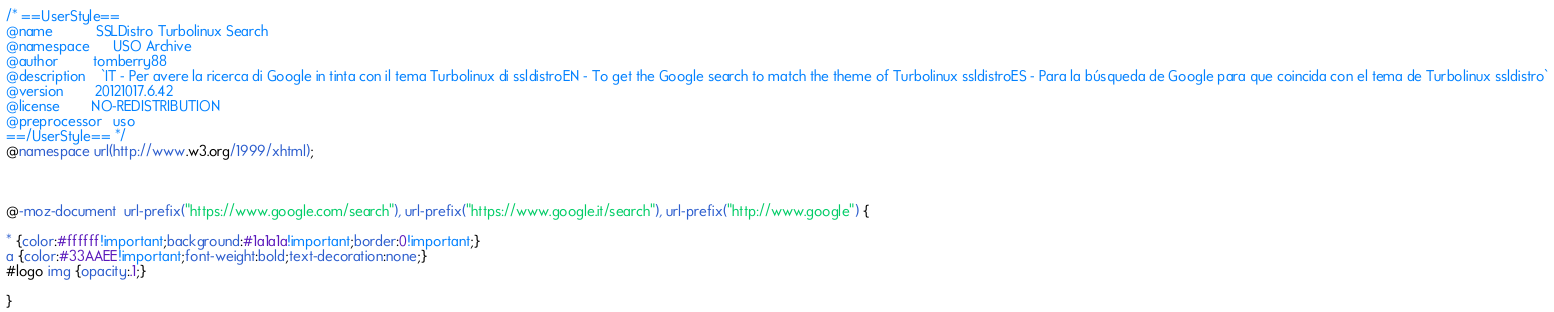<code> <loc_0><loc_0><loc_500><loc_500><_CSS_>/* ==UserStyle==
@name           SSLDistro Turbolinux Search
@namespace      USO Archive
@author         tomberry88
@description    `IT - Per avere la ricerca di Google in tinta con il tema Turbolinux di ssldistroEN - To get the Google search to match the theme of Turbolinux ssldistroES - Para la búsqueda de Google para que coincida con el tema de Turbolinux ssldistro`
@version        20121017.6.42
@license        NO-REDISTRIBUTION
@preprocessor   uso
==/UserStyle== */
@namespace url(http://www.w3.org/1999/xhtml);



@-moz-document  url-prefix("https://www.google.com/search"), url-prefix("https://www.google.it/search"), url-prefix("http://www.google") {

* {color:#ffffff!important;background:#1a1a1a!important;border:0!important;}
a {color:#33AAEE!important;font-weight:bold;text-decoration:none;}
#logo img {opacity:.1;}

}</code> 